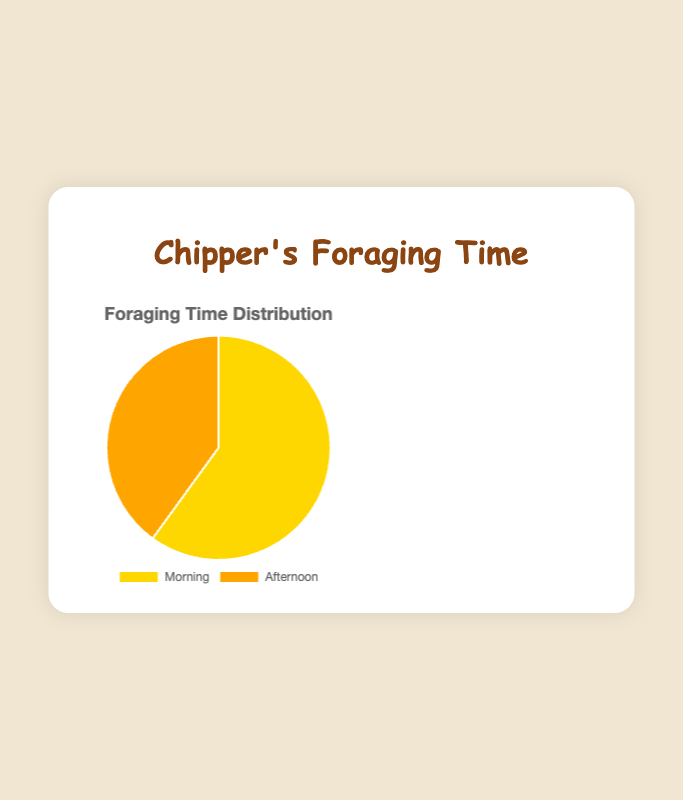What's the total foraging time for Chipper? To find the total foraging time, add the time spent foraging in the morning (45 minutes) and the afternoon (30 minutes). So, 45 + 30 = 75 minutes.
Answer: 75 minutes Which foraging period does Chipper spend more time in, morning or afternoon? By comparing the times, Chipper spends 45 minutes in the morning and 30 minutes in the afternoon. 45 is greater than 30, so Chipper spends more time foraging in the morning.
Answer: Morning What fraction of Chipper's total foraging time is spent in the afternoon? First, find Chipper's total foraging time (45 + 30 = 75 minutes). Then, divide the afternoon foraging time by the total, 30/75 = 2/5 or 0.4 in decimal form.
Answer: 2/5 or 0.4 If Chipper were to double the time spent foraging in the afternoon, how would the pie chart's sectors change? Initially, Chipper's afternoon time is 30 minutes. Doubling this makes it 60 minutes. New total foraging time is 45 (morning) + 60 (afternoon) = 105 minutes. Morning would be 45/105 of the chart, and afternoon would be 60/105 of the chart.
Answer: 45/105 in the morning, 60/105 in the afternoon Is the proportion of time Chipper spends foraging in the morning greater than 50%? Calculate the proportion: morning foraging time is 45 minutes out of a total of 75 minutes. 45/75 = 3/5, which is 0.6 or 60%. Since 60% is greater than 50%, the proportion is indeed greater.
Answer: Yes What is the color used to represent the afternoon foraging time? The pie chart uses a distinct color for each segment. The afternoon foraging time is represented by the orange segment.
Answer: Orange If Chipper decided to split his afternoon foraging time evenly between the morning and afternoon, what would be the new foraging times for each period? Initially, afternoon is 30 minutes. Splitting this in half gives 15 minutes each to morning and afternoon. Morning would then be 45 + 15 = 60 minutes, and afternoon would be 15 minutes.
Answer: Morning: 60 minutes, Afternoon: 15 minutes How much more time does Chipper spend foraging in the morning compared to the afternoon? Subtract the afternoon foraging time from the morning foraging time. 45 minutes (morning) - 30 minutes (afternoon) = 15 minutes.
Answer: 15 minutes What percentage of Chipper's foraging time is spent in the morning? To find the percentage, divide the morning time by the total time and multiply by 100. (45/75) * 100 = 60%.
Answer: 60% What is the combined duration of Chipper and Nibbles' afternoon foraging times? Add Chipper's (30 minutes) and Nibbles' (35 minutes) afternoon foraging times together. 30 + 35 = 65 minutes.
Answer: 65 minutes 